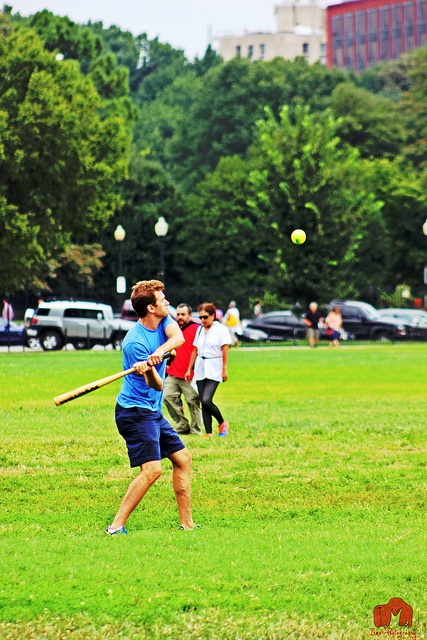Describe the objects in this image and their specific colors. I can see people in white, black, tan, and navy tones, car in white, black, lightgray, darkgray, and lightblue tones, people in white, black, tan, and gray tones, people in white, red, black, and olive tones, and car in white, black, lightgray, and gray tones in this image. 